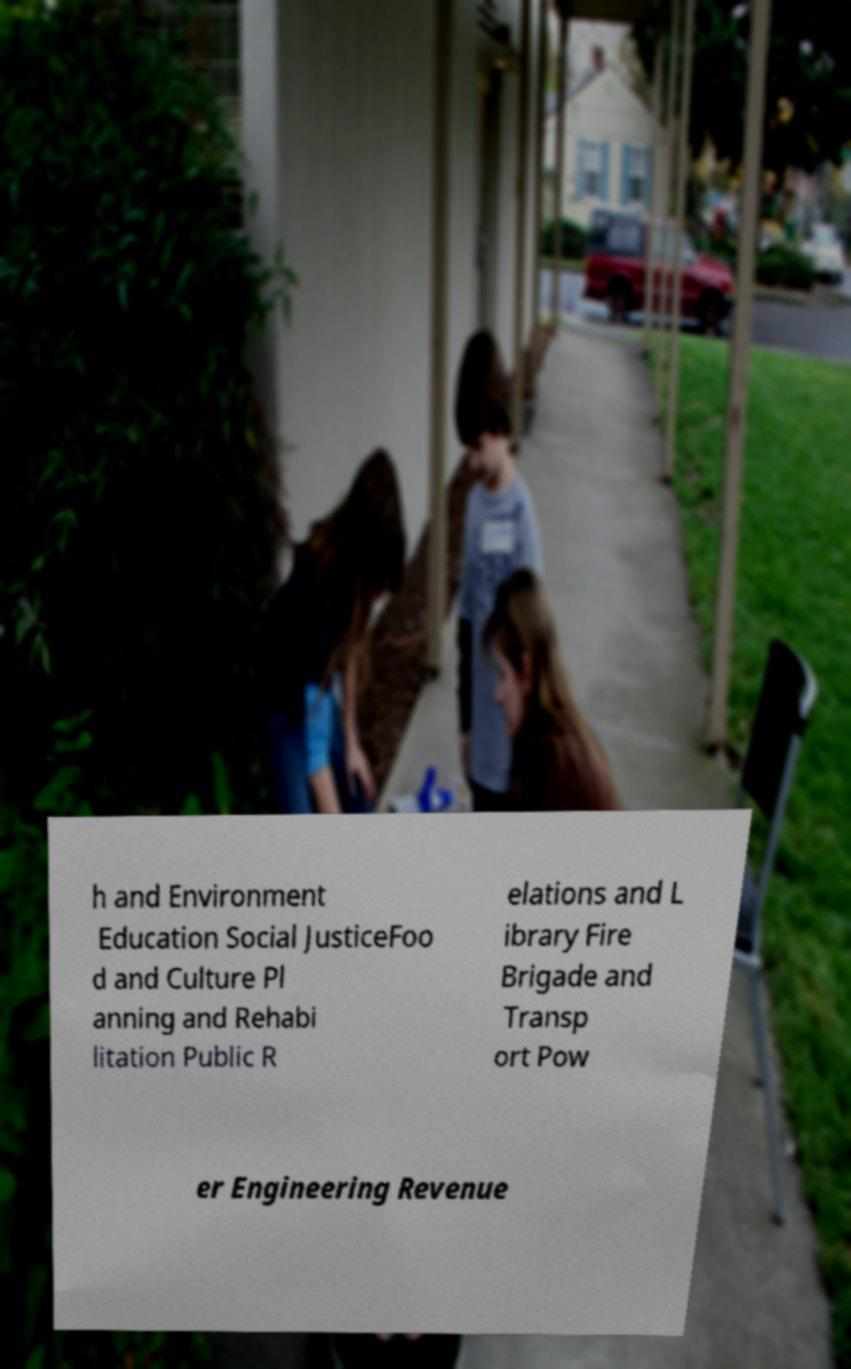Could you extract and type out the text from this image? h and Environment Education Social JusticeFoo d and Culture Pl anning and Rehabi litation Public R elations and L ibrary Fire Brigade and Transp ort Pow er Engineering Revenue 